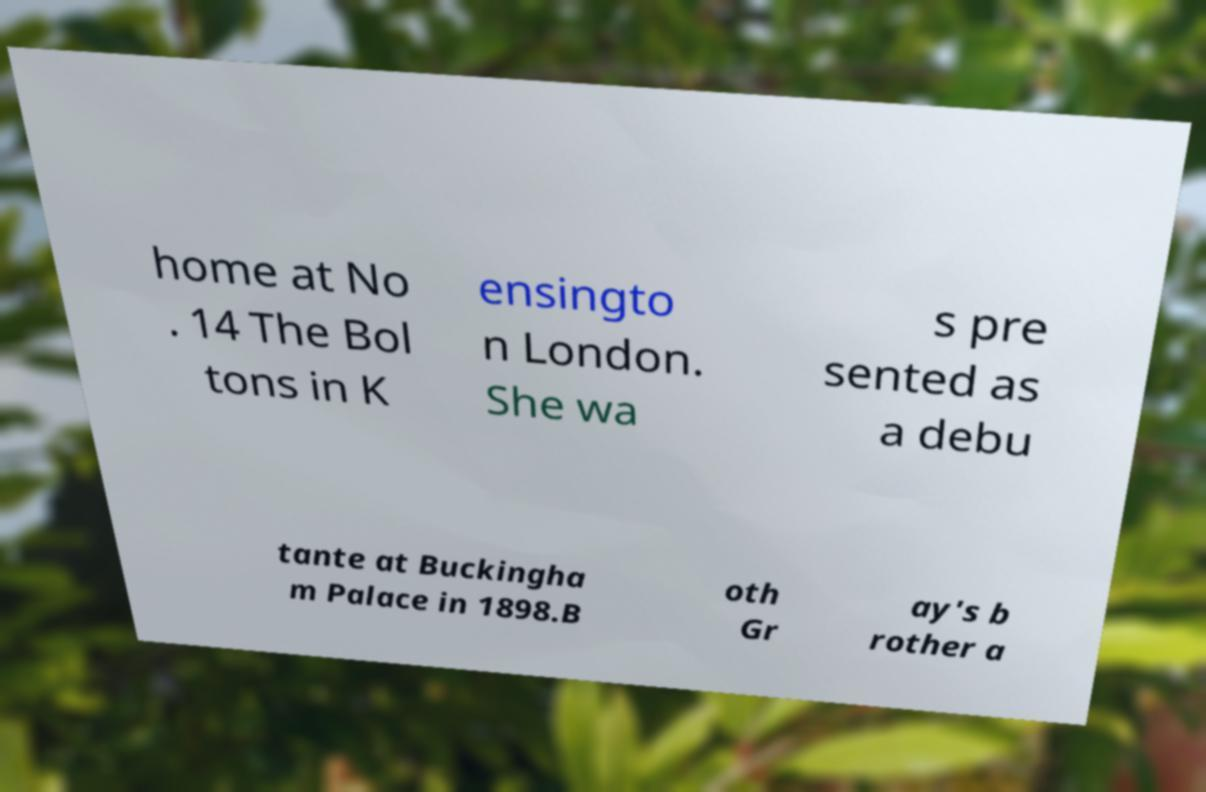Can you read and provide the text displayed in the image?This photo seems to have some interesting text. Can you extract and type it out for me? home at No . 14 The Bol tons in K ensingto n London. She wa s pre sented as a debu tante at Buckingha m Palace in 1898.B oth Gr ay's b rother a 